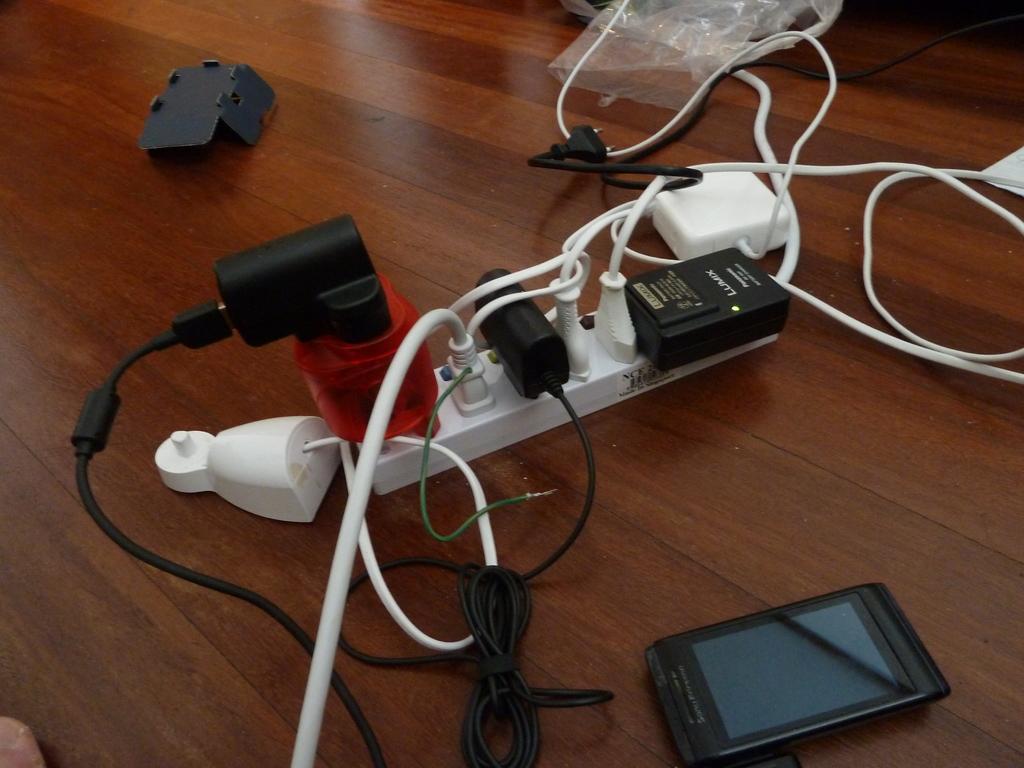How would you summarize this image in a sentence or two? In this image I can see a mobile phone and many wires are connected to a socket and there is a polythene cover on a wooden surface. 